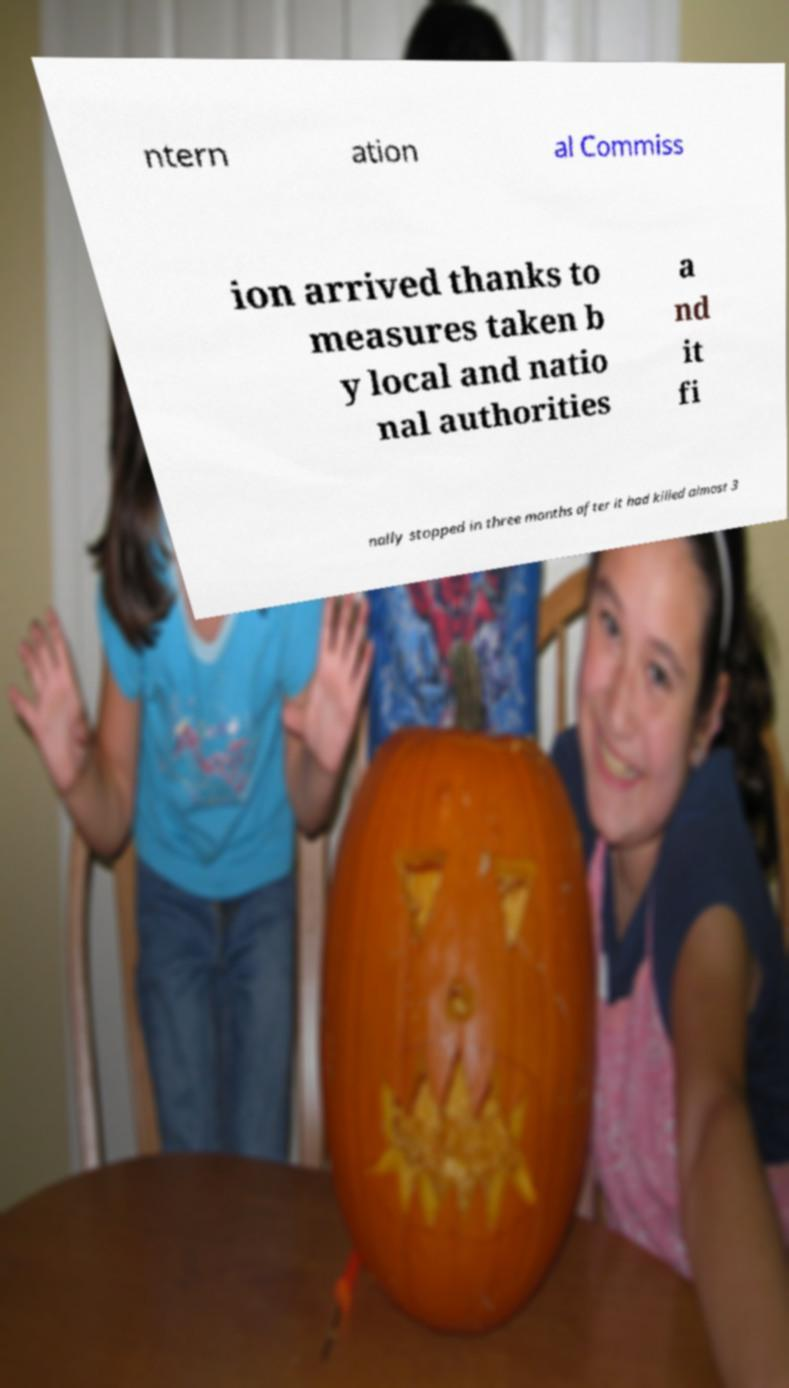What messages or text are displayed in this image? I need them in a readable, typed format. ntern ation al Commiss ion arrived thanks to measures taken b y local and natio nal authorities a nd it fi nally stopped in three months after it had killed almost 3 